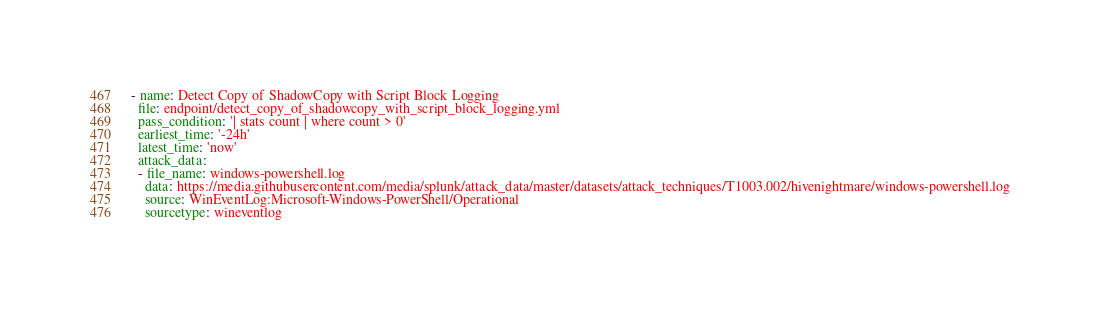<code> <loc_0><loc_0><loc_500><loc_500><_YAML_>- name: Detect Copy of ShadowCopy with Script Block Logging
  file: endpoint/detect_copy_of_shadowcopy_with_script_block_logging.yml
  pass_condition: '| stats count | where count > 0'
  earliest_time: '-24h'
  latest_time: 'now'
  attack_data:
  - file_name: windows-powershell.log
    data: https://media.githubusercontent.com/media/splunk/attack_data/master/datasets/attack_techniques/T1003.002/hivenightmare/windows-powershell.log
    source: WinEventLog:Microsoft-Windows-PowerShell/Operational
    sourcetype: wineventlog</code> 